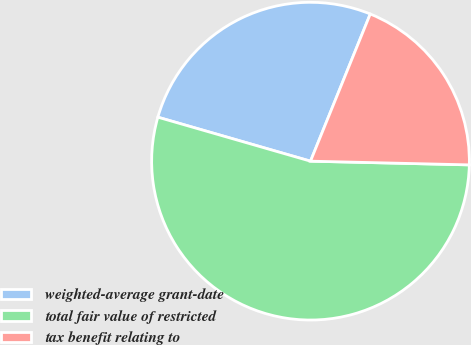Convert chart to OTSL. <chart><loc_0><loc_0><loc_500><loc_500><pie_chart><fcel>weighted-average grant-date<fcel>total fair value of restricted<fcel>tax benefit relating to<nl><fcel>26.67%<fcel>54.09%<fcel>19.23%<nl></chart> 